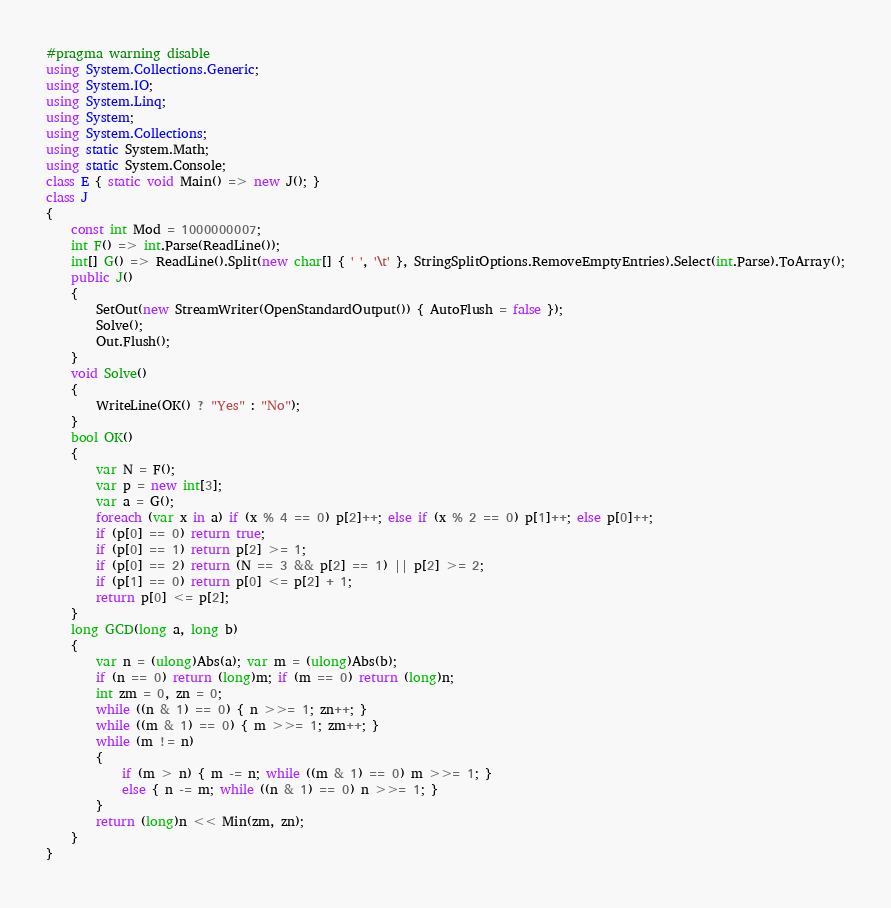Convert code to text. <code><loc_0><loc_0><loc_500><loc_500><_C#_>#pragma warning disable
using System.Collections.Generic;
using System.IO;
using System.Linq;
using System;
using System.Collections;
using static System.Math;
using static System.Console;
class E { static void Main() => new J(); }
class J
{
	const int Mod = 1000000007;
	int F() => int.Parse(ReadLine());
	int[] G() => ReadLine().Split(new char[] { ' ', '\t' }, StringSplitOptions.RemoveEmptyEntries).Select(int.Parse).ToArray();
	public J()
	{
		SetOut(new StreamWriter(OpenStandardOutput()) { AutoFlush = false });
		Solve();
		Out.Flush();
	}
	void Solve()
	{
		WriteLine(OK() ? "Yes" : "No");
	}
	bool OK()
	{
		var N = F();
		var p = new int[3];
		var a = G();
		foreach (var x in a) if (x % 4 == 0) p[2]++; else if (x % 2 == 0) p[1]++; else p[0]++;
		if (p[0] == 0) return true;
		if (p[0] == 1) return p[2] >= 1;
		if (p[0] == 2) return (N == 3 && p[2] == 1) || p[2] >= 2;
		if (p[1] == 0) return p[0] <= p[2] + 1;
		return p[0] <= p[2];
	}
	long GCD(long a, long b)
	{
		var n = (ulong)Abs(a); var m = (ulong)Abs(b);
		if (n == 0) return (long)m; if (m == 0) return (long)n;
		int zm = 0, zn = 0;
		while ((n & 1) == 0) { n >>= 1; zn++; }
		while ((m & 1) == 0) { m >>= 1; zm++; }
		while (m != n)
		{
			if (m > n) { m -= n; while ((m & 1) == 0) m >>= 1; }
			else { n -= m; while ((n & 1) == 0) n >>= 1; }
		}
		return (long)n << Min(zm, zn);
	}
}</code> 